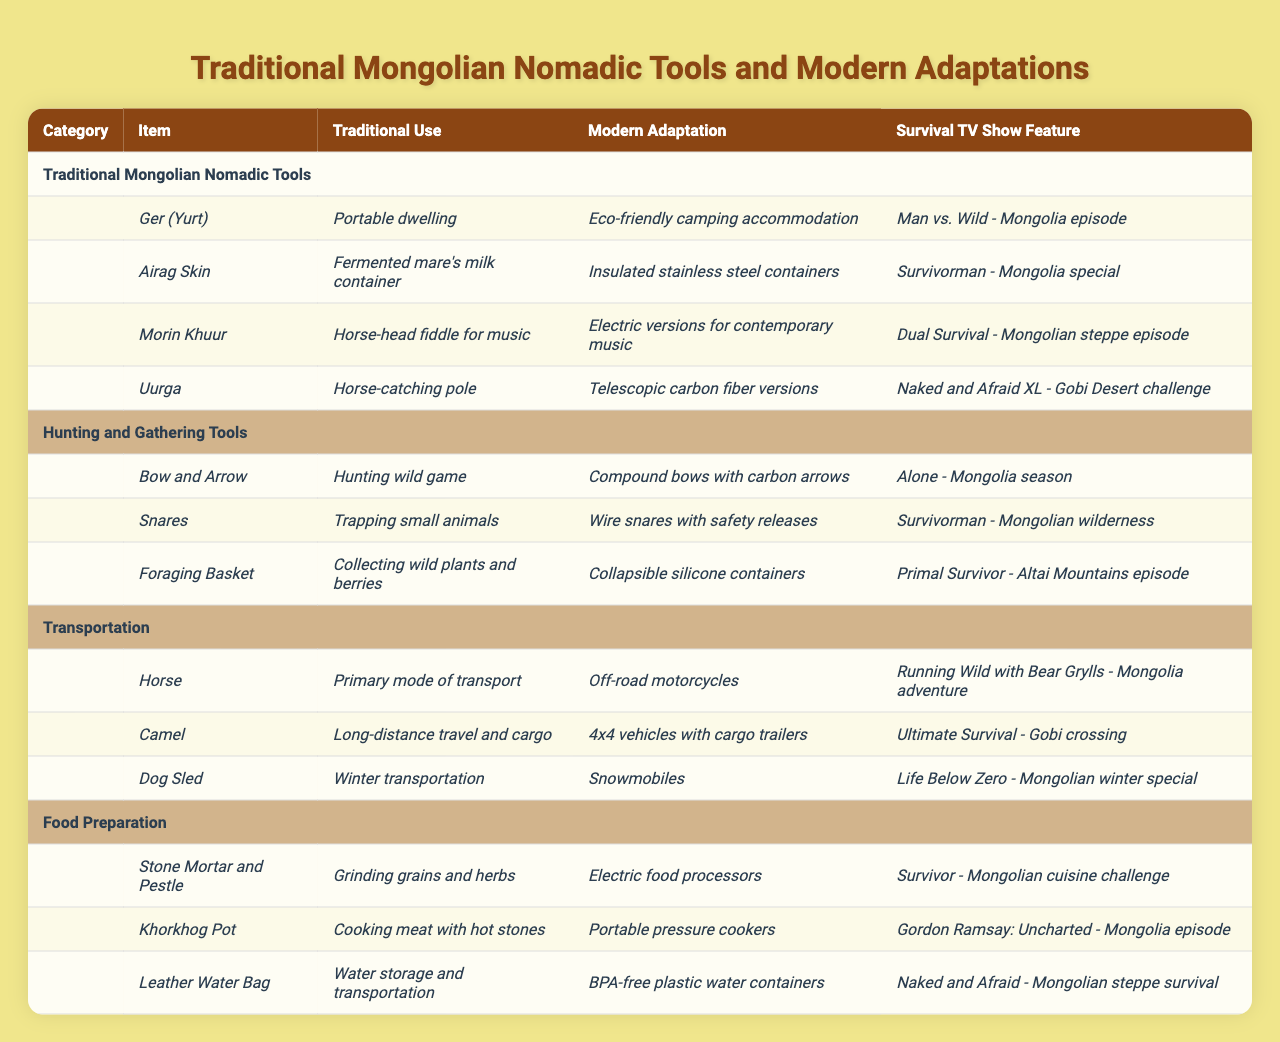What traditional use does the Ger (Yurt) serve? The table shows that the Ger (Yurt) is traditionally used as a portable dwelling.
Answer: Portable dwelling What modern adaptation is associated with the Morin Khuur? According to the table, the Morin Khuur has been adapted to electric versions for contemporary music.
Answer: Electric versions for contemporary music Is Airag Skin used for storing food items? The table indicates that Airag Skin is used as a fermented mare's milk container, which classifies it as a food storage tool.
Answer: Yes Which tool is featured in the "Naked and Afraid XL - Gobi Desert challenge"? The table lists Uurga as the tool featured in the "Naked and Afraid XL - Gobi Desert challenge."
Answer: Uurga How many different categories of tools are mentioned in the table? The table displays four categories: Traditional Mongolian Nomadic Tools, Hunting and Gathering Tools, Transportation, and Food Preparation. Thus, there are four categories mentioned.
Answer: 4 Which tool is used for cooking meat with hot stones? The Khorkhog Pot is identified in the table as the tool used for cooking meat with hot stones.
Answer: Khorkhog Pot In what survival TV show is the Bow and Arrow featured? The Bow and Arrow is featured in the "Alone - Mongolia season," as indicated by the respective entry in the table.
Answer: Alone - Mongolia season What is the modern adaptation of the Leather Water Bag? The table states that the modern adaptation of the Leather Water Bag is BPA-free plastic water containers.
Answer: BPA-free plastic water containers Does the Camel have a traditional use related to transport? The table confirms that the Camel's traditional use is for long-distance travel and cargo, indicating that it is related to transport.
Answer: Yes What is the combined purpose of the Foraging Basket? The Foraging Basket is traditionally used for collecting wild plants and berries, and the modern adaptation is collapsible silicone containers, serving the same purpose of gathering food items.
Answer: Collecting wild plants and berries What survival TV show features the modern adaptation of the Dog Sled? The table specifies that the modern adaptation of the Dog Sled (snowmobiles) is featured in "Life Below Zero - Mongolian winter special."
Answer: Life Below Zero - Mongolian winter special 